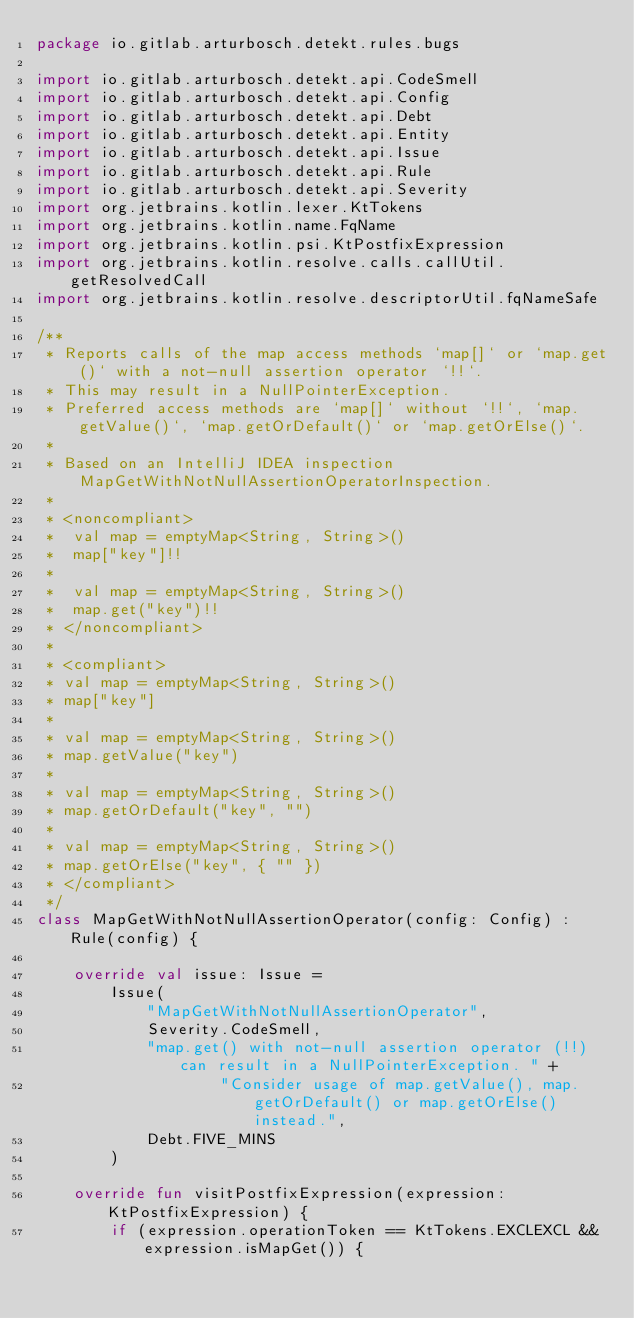Convert code to text. <code><loc_0><loc_0><loc_500><loc_500><_Kotlin_>package io.gitlab.arturbosch.detekt.rules.bugs

import io.gitlab.arturbosch.detekt.api.CodeSmell
import io.gitlab.arturbosch.detekt.api.Config
import io.gitlab.arturbosch.detekt.api.Debt
import io.gitlab.arturbosch.detekt.api.Entity
import io.gitlab.arturbosch.detekt.api.Issue
import io.gitlab.arturbosch.detekt.api.Rule
import io.gitlab.arturbosch.detekt.api.Severity
import org.jetbrains.kotlin.lexer.KtTokens
import org.jetbrains.kotlin.name.FqName
import org.jetbrains.kotlin.psi.KtPostfixExpression
import org.jetbrains.kotlin.resolve.calls.callUtil.getResolvedCall
import org.jetbrains.kotlin.resolve.descriptorUtil.fqNameSafe

/**
 * Reports calls of the map access methods `map[]` or `map.get()` with a not-null assertion operator `!!`.
 * This may result in a NullPointerException.
 * Preferred access methods are `map[]` without `!!`, `map.getValue()`, `map.getOrDefault()` or `map.getOrElse()`.
 *
 * Based on an IntelliJ IDEA inspection MapGetWithNotNullAssertionOperatorInspection.
 *
 * <noncompliant>
 *  val map = emptyMap<String, String>()
 *  map["key"]!!
 *
 *  val map = emptyMap<String, String>()
 *  map.get("key")!!
 * </noncompliant>
 *
 * <compliant>
 * val map = emptyMap<String, String>()
 * map["key"]
 *
 * val map = emptyMap<String, String>()
 * map.getValue("key")
 *
 * val map = emptyMap<String, String>()
 * map.getOrDefault("key", "")
 *
 * val map = emptyMap<String, String>()
 * map.getOrElse("key", { "" })
 * </compliant>
 */
class MapGetWithNotNullAssertionOperator(config: Config) : Rule(config) {

    override val issue: Issue =
        Issue(
            "MapGetWithNotNullAssertionOperator",
            Severity.CodeSmell,
            "map.get() with not-null assertion operator (!!) can result in a NullPointerException. " +
                    "Consider usage of map.getValue(), map.getOrDefault() or map.getOrElse() instead.",
            Debt.FIVE_MINS
        )

    override fun visitPostfixExpression(expression: KtPostfixExpression) {
        if (expression.operationToken == KtTokens.EXCLEXCL && expression.isMapGet()) {</code> 